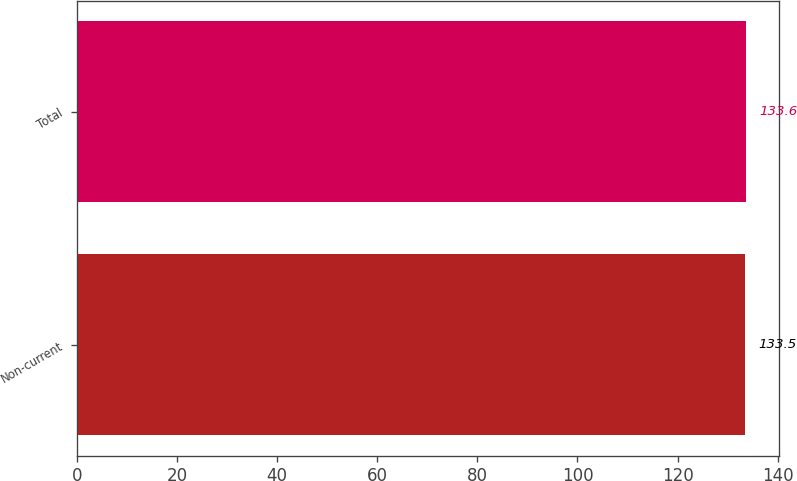Convert chart to OTSL. <chart><loc_0><loc_0><loc_500><loc_500><bar_chart><fcel>Non-current<fcel>Total<nl><fcel>133.5<fcel>133.6<nl></chart> 